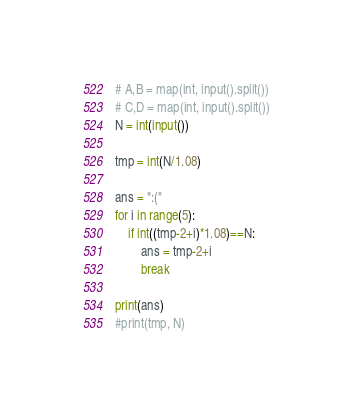<code> <loc_0><loc_0><loc_500><loc_500><_Python_># A,B = map(int, input().split())
# C,D = map(int, input().split())
N = int(input())

tmp = int(N/1.08)

ans = ":("
for i in range(5):
    if int((tmp-2+i)*1.08)==N:
        ans = tmp-2+i
        break
    
print(ans)
#print(tmp, N)
</code> 